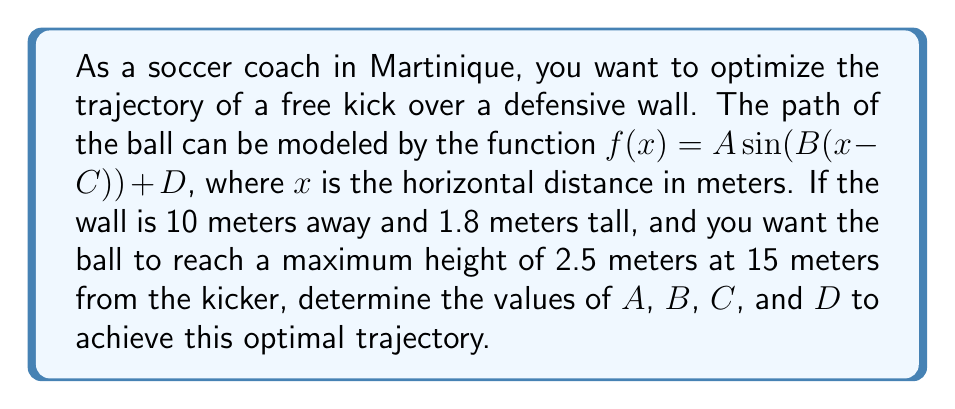Could you help me with this problem? Let's approach this step-by-step:

1) The general form of a transformed sine function is:
   $f(x) = A \sin(B(x-C)) + D$
   where:
   $A$ is the amplitude
   $B$ affects the period
   $C$ is the horizontal shift
   $D$ is the vertical shift

2) We know the following:
   - The ball should reach its maximum height at $x = 15$ m
   - The maximum height should be 2.5 m
   - The ball should clear the wall at $x = 10$ m, where the height is 1.8 m

3) For a sine function, the maximum occurs at $\frac{\pi}{2}$ radians. So:
   $B(15-C) = \frac{\pi}{2}$

4) The amplitude $A$ is half the distance between the maximum and minimum points. The minimum point will be at ground level (0 m), so:
   $A = \frac{2.5 - 0}{2} = 1.25$

5) The vertical shift $D$ will be the average of the maximum and minimum heights:
   $D = \frac{2.5 + 0}{2} = 1.25$

6) Now we can use the point $(10, 1.8)$ to find $B$ and $C$:
   $1.8 = 1.25 \sin(B(10-C)) + 1.25$
   $0.55 = 1.25 \sin(B(10-C))$
   $0.44 = \sin(B(10-C))$
   $B(10-C) = \arcsin(0.44) \approx 0.4554$

7) Combining this with the equation from step 3:
   $B(15-C) = \frac{\pi}{2}$
   $B(10-C) = 0.4554$

8) Subtracting these equations:
   $5B = \frac{\pi}{2} - 0.4554$
   $B = \frac{\frac{\pi}{2} - 0.4554}{5} \approx 0.2636$

9) Substituting this back into the equation from step 3:
   $0.2636(15-C) = \frac{\pi}{2}$
   $15-C = \frac{\pi}{2 * 0.2636} \approx 5.9605$
   $C = 15 - 5.9605 \approx 9.0395$

Therefore, the optimal trajectory function is:
$f(x) = 1.25 \sin(0.2636(x-9.0395)) + 1.25$
Answer: $A = 1.25$, $B \approx 0.2636$, $C \approx 9.0395$, $D = 1.25$ 